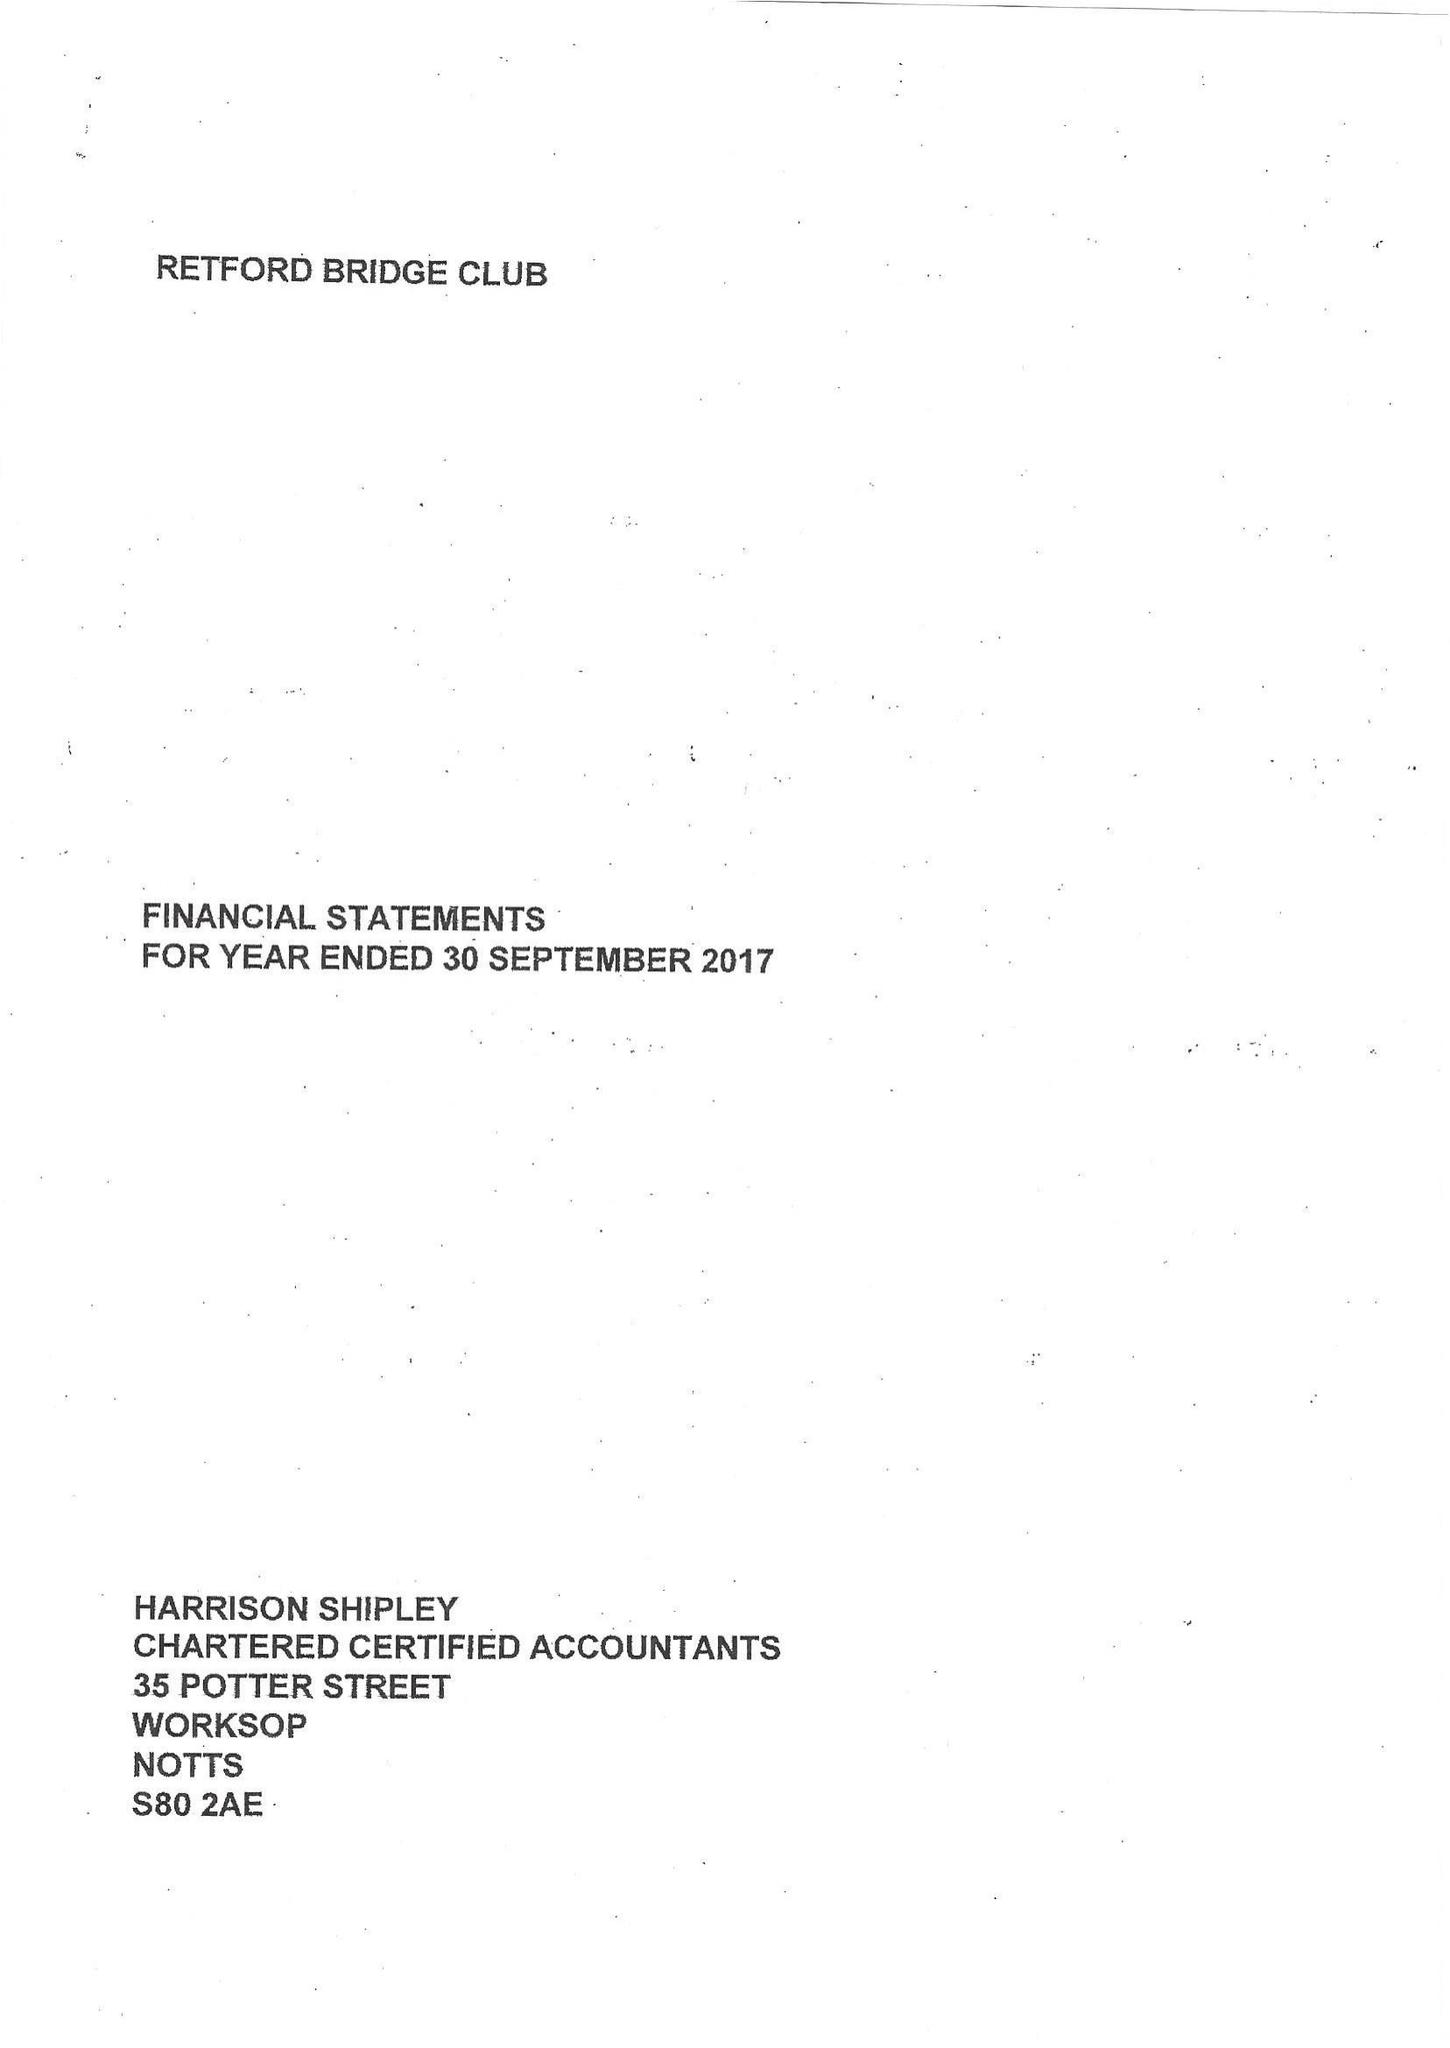What is the value for the charity_name?
Answer the question using a single word or phrase. Retford Bridge Club 